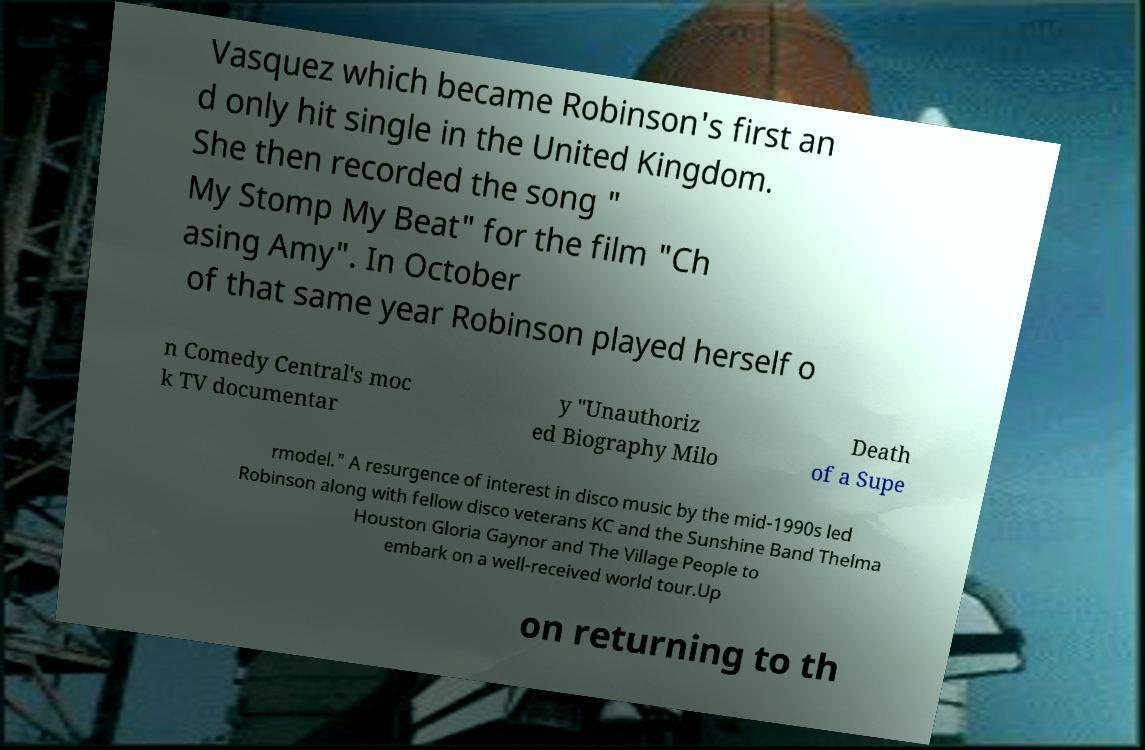Could you assist in decoding the text presented in this image and type it out clearly? Vasquez which became Robinson's first an d only hit single in the United Kingdom. She then recorded the song " My Stomp My Beat" for the film "Ch asing Amy". In October of that same year Robinson played herself o n Comedy Central's moc k TV documentar y "Unauthoriz ed Biography Milo Death of a Supe rmodel." A resurgence of interest in disco music by the mid-1990s led Robinson along with fellow disco veterans KC and the Sunshine Band Thelma Houston Gloria Gaynor and The Village People to embark on a well-received world tour.Up on returning to th 